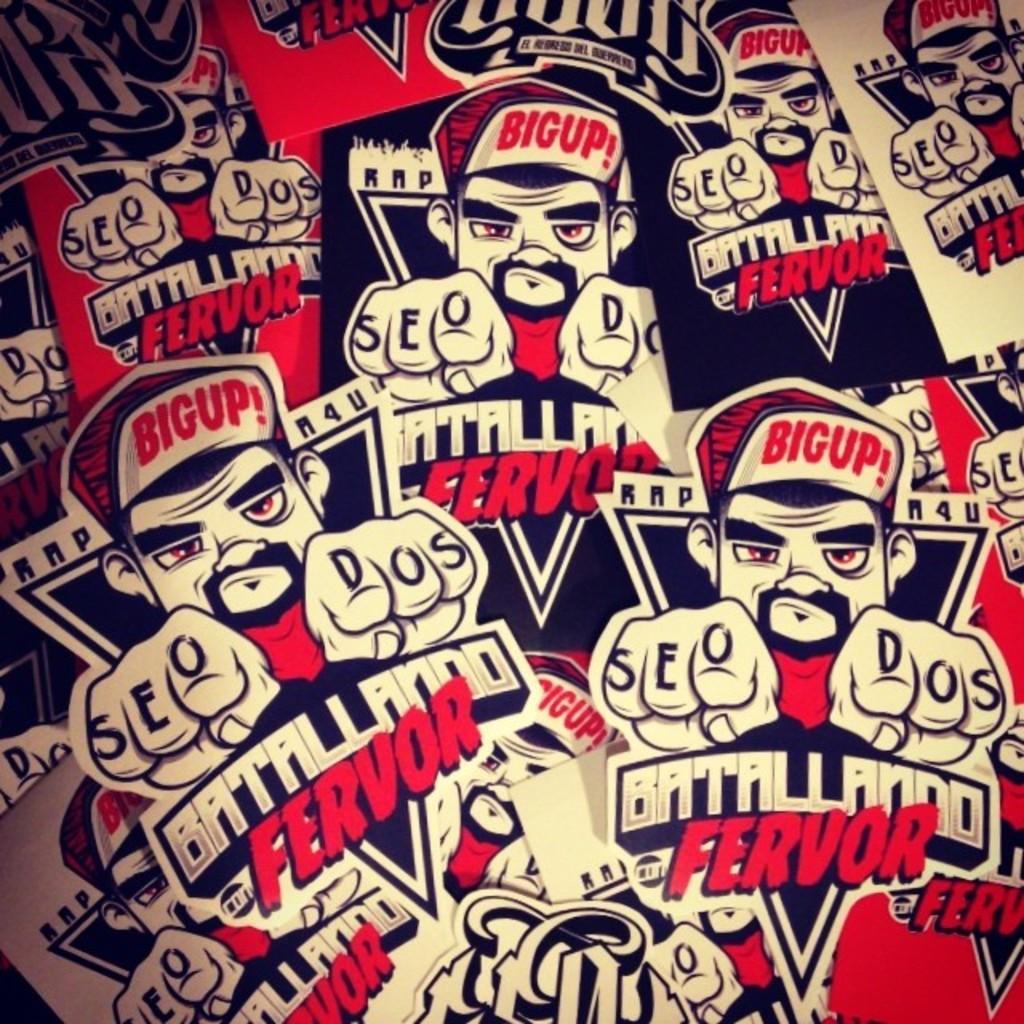Describe this image in one or two sentences. In this picture, we can see some posters of some images and text on it. 